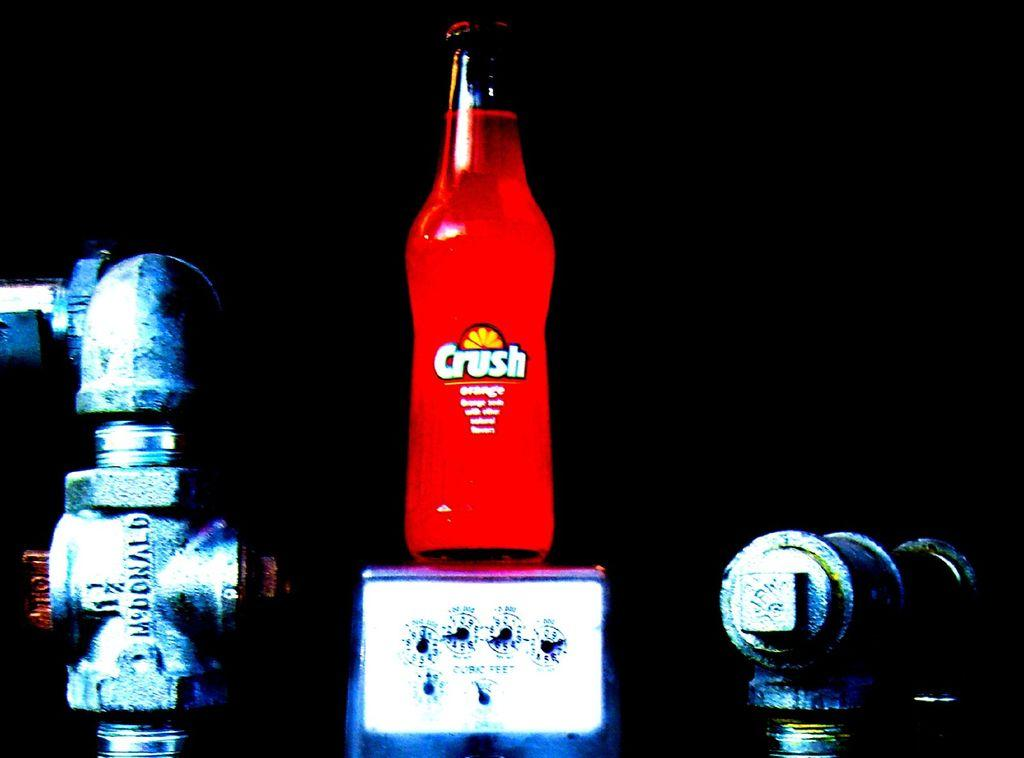<image>
Describe the image concisely. A bottle of Crush sits in a dark room. 